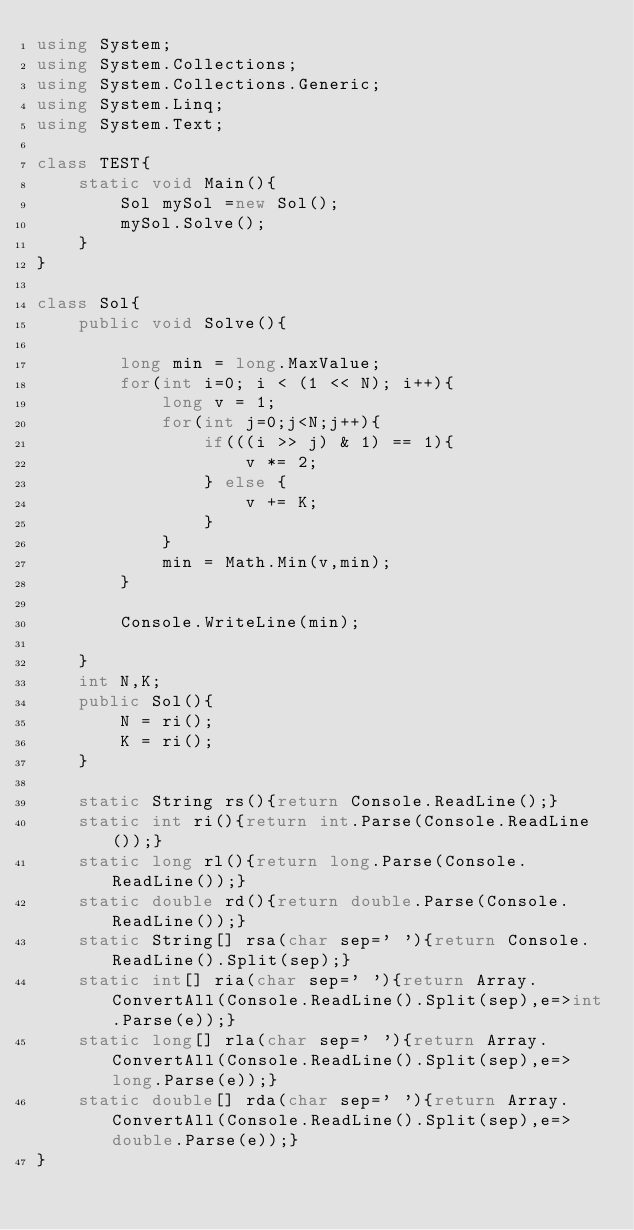<code> <loc_0><loc_0><loc_500><loc_500><_C#_>using System;
using System.Collections;
using System.Collections.Generic;
using System.Linq;
using System.Text;

class TEST{
	static void Main(){
		Sol mySol =new Sol();
		mySol.Solve();
	}
}

class Sol{
	public void Solve(){
		
		long min = long.MaxValue;
		for(int i=0; i < (1 << N); i++){
			long v = 1;
			for(int j=0;j<N;j++){
				if(((i >> j) & 1) == 1){
					v *= 2;
				} else {
					v += K;
				}
			}
			min = Math.Min(v,min);
		}
		
		Console.WriteLine(min);
		
	}
	int N,K;
	public Sol(){
		N = ri();
		K = ri();
	}

	static String rs(){return Console.ReadLine();}
	static int ri(){return int.Parse(Console.ReadLine());}
	static long rl(){return long.Parse(Console.ReadLine());}
	static double rd(){return double.Parse(Console.ReadLine());}
	static String[] rsa(char sep=' '){return Console.ReadLine().Split(sep);}
	static int[] ria(char sep=' '){return Array.ConvertAll(Console.ReadLine().Split(sep),e=>int.Parse(e));}
	static long[] rla(char sep=' '){return Array.ConvertAll(Console.ReadLine().Split(sep),e=>long.Parse(e));}
	static double[] rda(char sep=' '){return Array.ConvertAll(Console.ReadLine().Split(sep),e=>double.Parse(e));}
}
</code> 